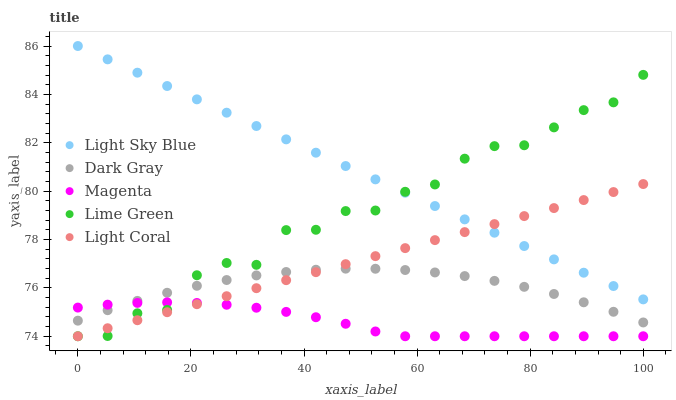Does Magenta have the minimum area under the curve?
Answer yes or no. Yes. Does Light Sky Blue have the maximum area under the curve?
Answer yes or no. Yes. Does Light Coral have the minimum area under the curve?
Answer yes or no. No. Does Light Coral have the maximum area under the curve?
Answer yes or no. No. Is Light Sky Blue the smoothest?
Answer yes or no. Yes. Is Lime Green the roughest?
Answer yes or no. Yes. Is Light Coral the smoothest?
Answer yes or no. No. Is Light Coral the roughest?
Answer yes or no. No. Does Light Coral have the lowest value?
Answer yes or no. Yes. Does Light Sky Blue have the lowest value?
Answer yes or no. No. Does Light Sky Blue have the highest value?
Answer yes or no. Yes. Does Light Coral have the highest value?
Answer yes or no. No. Is Magenta less than Light Sky Blue?
Answer yes or no. Yes. Is Light Sky Blue greater than Dark Gray?
Answer yes or no. Yes. Does Light Sky Blue intersect Light Coral?
Answer yes or no. Yes. Is Light Sky Blue less than Light Coral?
Answer yes or no. No. Is Light Sky Blue greater than Light Coral?
Answer yes or no. No. Does Magenta intersect Light Sky Blue?
Answer yes or no. No. 